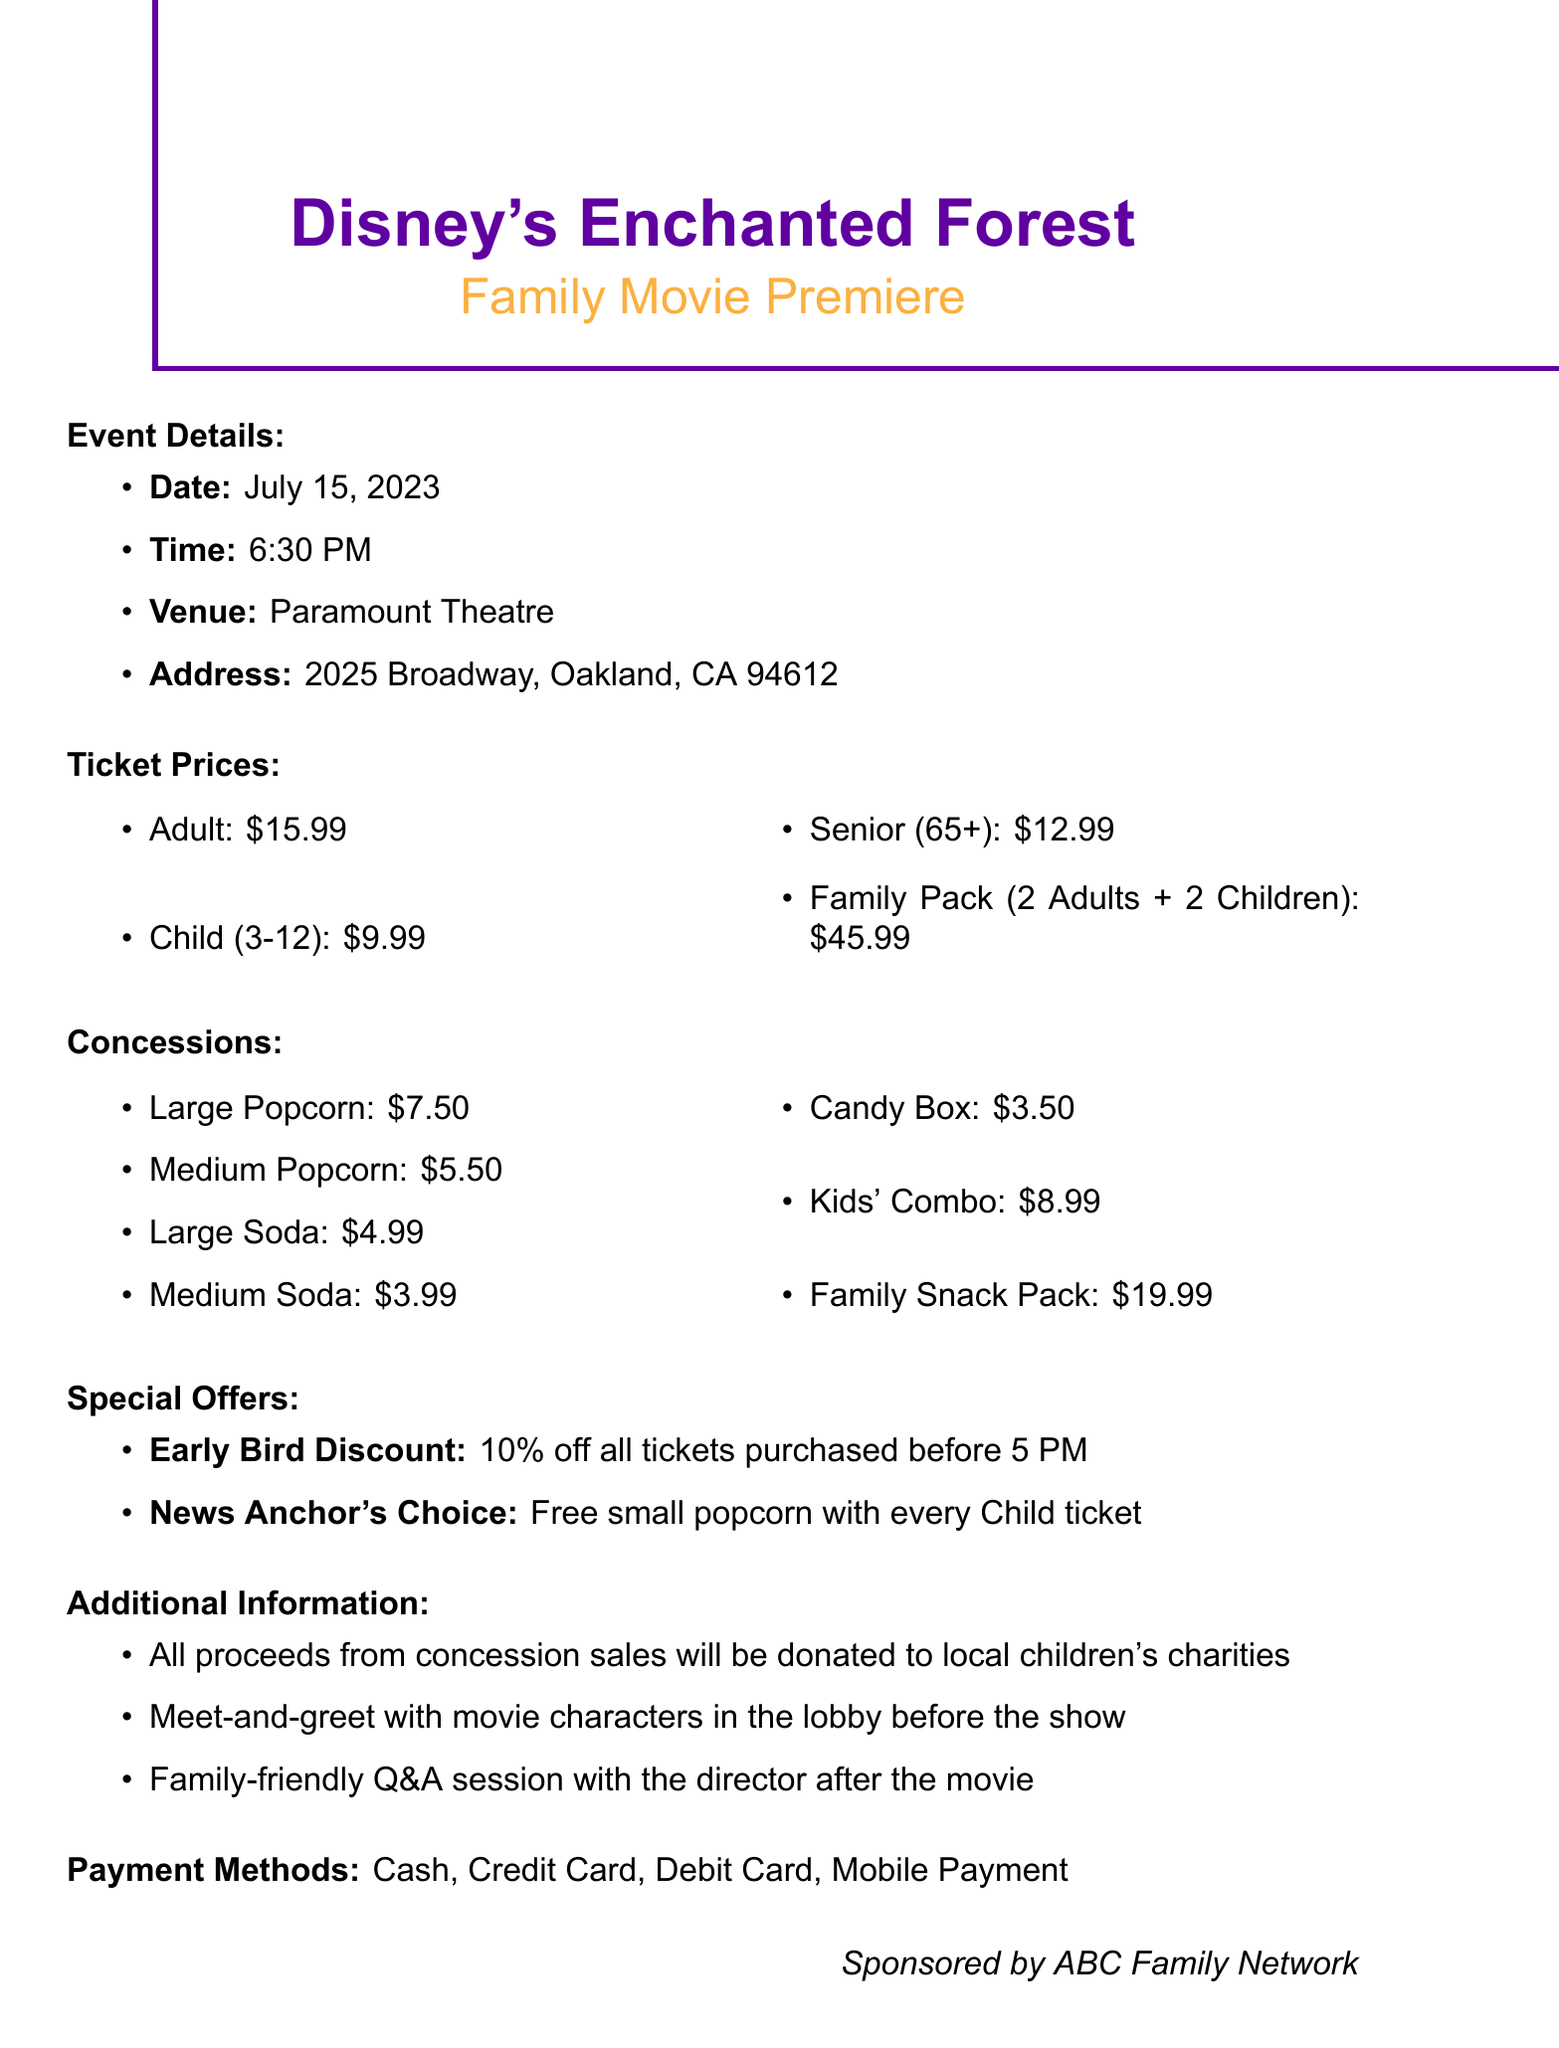What is the event name? The event name is provided explicitly in the document.
Answer: Disney's Enchanted Forest: Family Movie Premiere What is the date of the premiere? The date is mentioned clearly within the event details section.
Answer: July 15, 2023 How much is a Child ticket? The price for a Child ticket is specified under ticket prices.
Answer: 9.99 What is included in the Family Pack? The Family Pack includes two types of tickets, which is specified in the tickets section.
Answer: 2 Adults + 2 Children What is the price of the Large Popcorn? The price for the Large Popcorn is mentioned in the concessions section.
Answer: 7.50 What discount is offered for early bird ticket purchases? The discount is explicitly described in the special offers section.
Answer: 10% How does purchasing a Child ticket benefit the buyer? The special offer related to Child tickets provides additional value, which is explained in the document.
Answer: Free small popcorn What charity benefit does concession sales provide? The purpose of concession sales is described in the additional information section.
Answer: Donated to local children's charities 